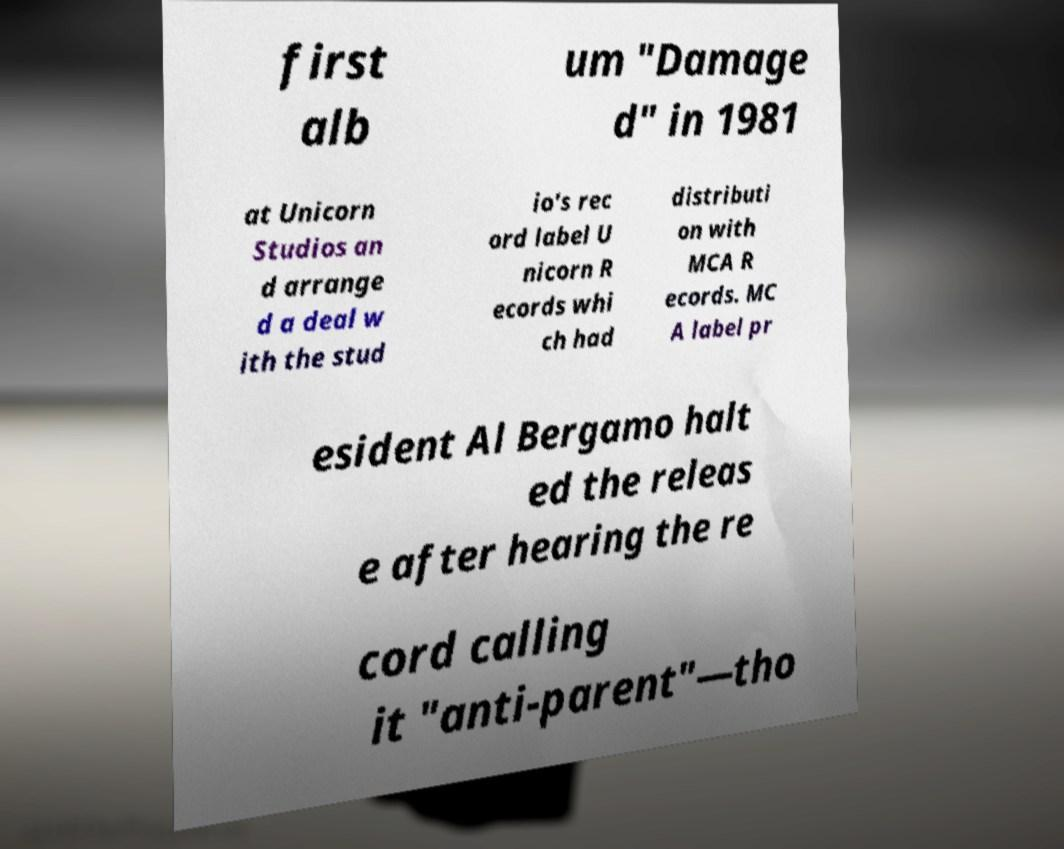What messages or text are displayed in this image? I need them in a readable, typed format. first alb um "Damage d" in 1981 at Unicorn Studios an d arrange d a deal w ith the stud io's rec ord label U nicorn R ecords whi ch had distributi on with MCA R ecords. MC A label pr esident Al Bergamo halt ed the releas e after hearing the re cord calling it "anti-parent"—tho 